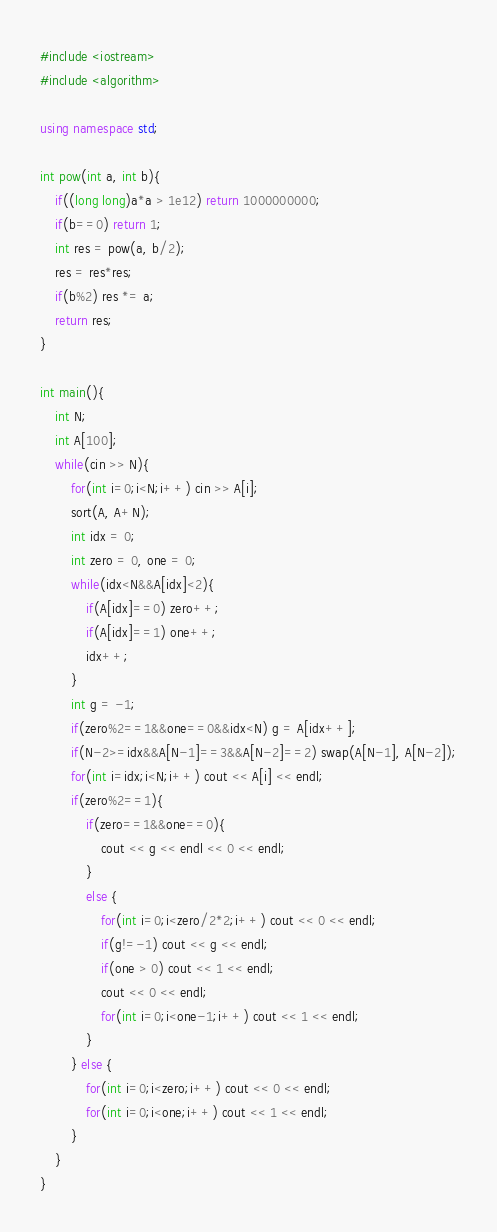Convert code to text. <code><loc_0><loc_0><loc_500><loc_500><_C++_>#include <iostream>
#include <algorithm>

using namespace std;

int pow(int a, int b){
	if((long long)a*a > 1e12) return 1000000000;
	if(b==0) return 1;
	int res = pow(a, b/2);
	res = res*res;
	if(b%2) res *= a;
	return res;
}

int main(){
	int N;
	int A[100];
	while(cin >> N){
		for(int i=0;i<N;i++) cin >> A[i];
		sort(A, A+N);
		int idx = 0;
		int zero = 0, one = 0;
		while(idx<N&&A[idx]<2){
			if(A[idx]==0) zero++;
			if(A[idx]==1) one++;
			idx++;
		}
		int g = -1;
		if(zero%2==1&&one==0&&idx<N) g = A[idx++];
		if(N-2>=idx&&A[N-1]==3&&A[N-2]==2) swap(A[N-1], A[N-2]);
		for(int i=idx;i<N;i++) cout << A[i] << endl;
		if(zero%2==1){
			if(zero==1&&one==0){
				cout << g << endl << 0 << endl;
			}
			else {
				for(int i=0;i<zero/2*2;i++) cout << 0 << endl;
				if(g!=-1) cout << g << endl;
				if(one > 0) cout << 1 << endl;
				cout << 0 << endl;
				for(int i=0;i<one-1;i++) cout << 1 << endl;
			}
		} else {
			for(int i=0;i<zero;i++) cout << 0 << endl;
			for(int i=0;i<one;i++) cout << 1 << endl;
		}
	}
}</code> 